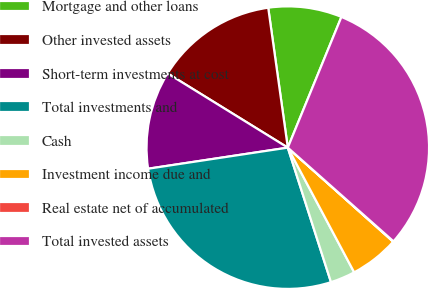<chart> <loc_0><loc_0><loc_500><loc_500><pie_chart><fcel>Mortgage and other loans<fcel>Other invested assets<fcel>Short-term investments at cost<fcel>Total investments and<fcel>Cash<fcel>Investment income due and<fcel>Real estate net of accumulated<fcel>Total invested assets<nl><fcel>8.41%<fcel>13.98%<fcel>11.19%<fcel>27.56%<fcel>2.84%<fcel>5.62%<fcel>0.05%<fcel>30.35%<nl></chart> 